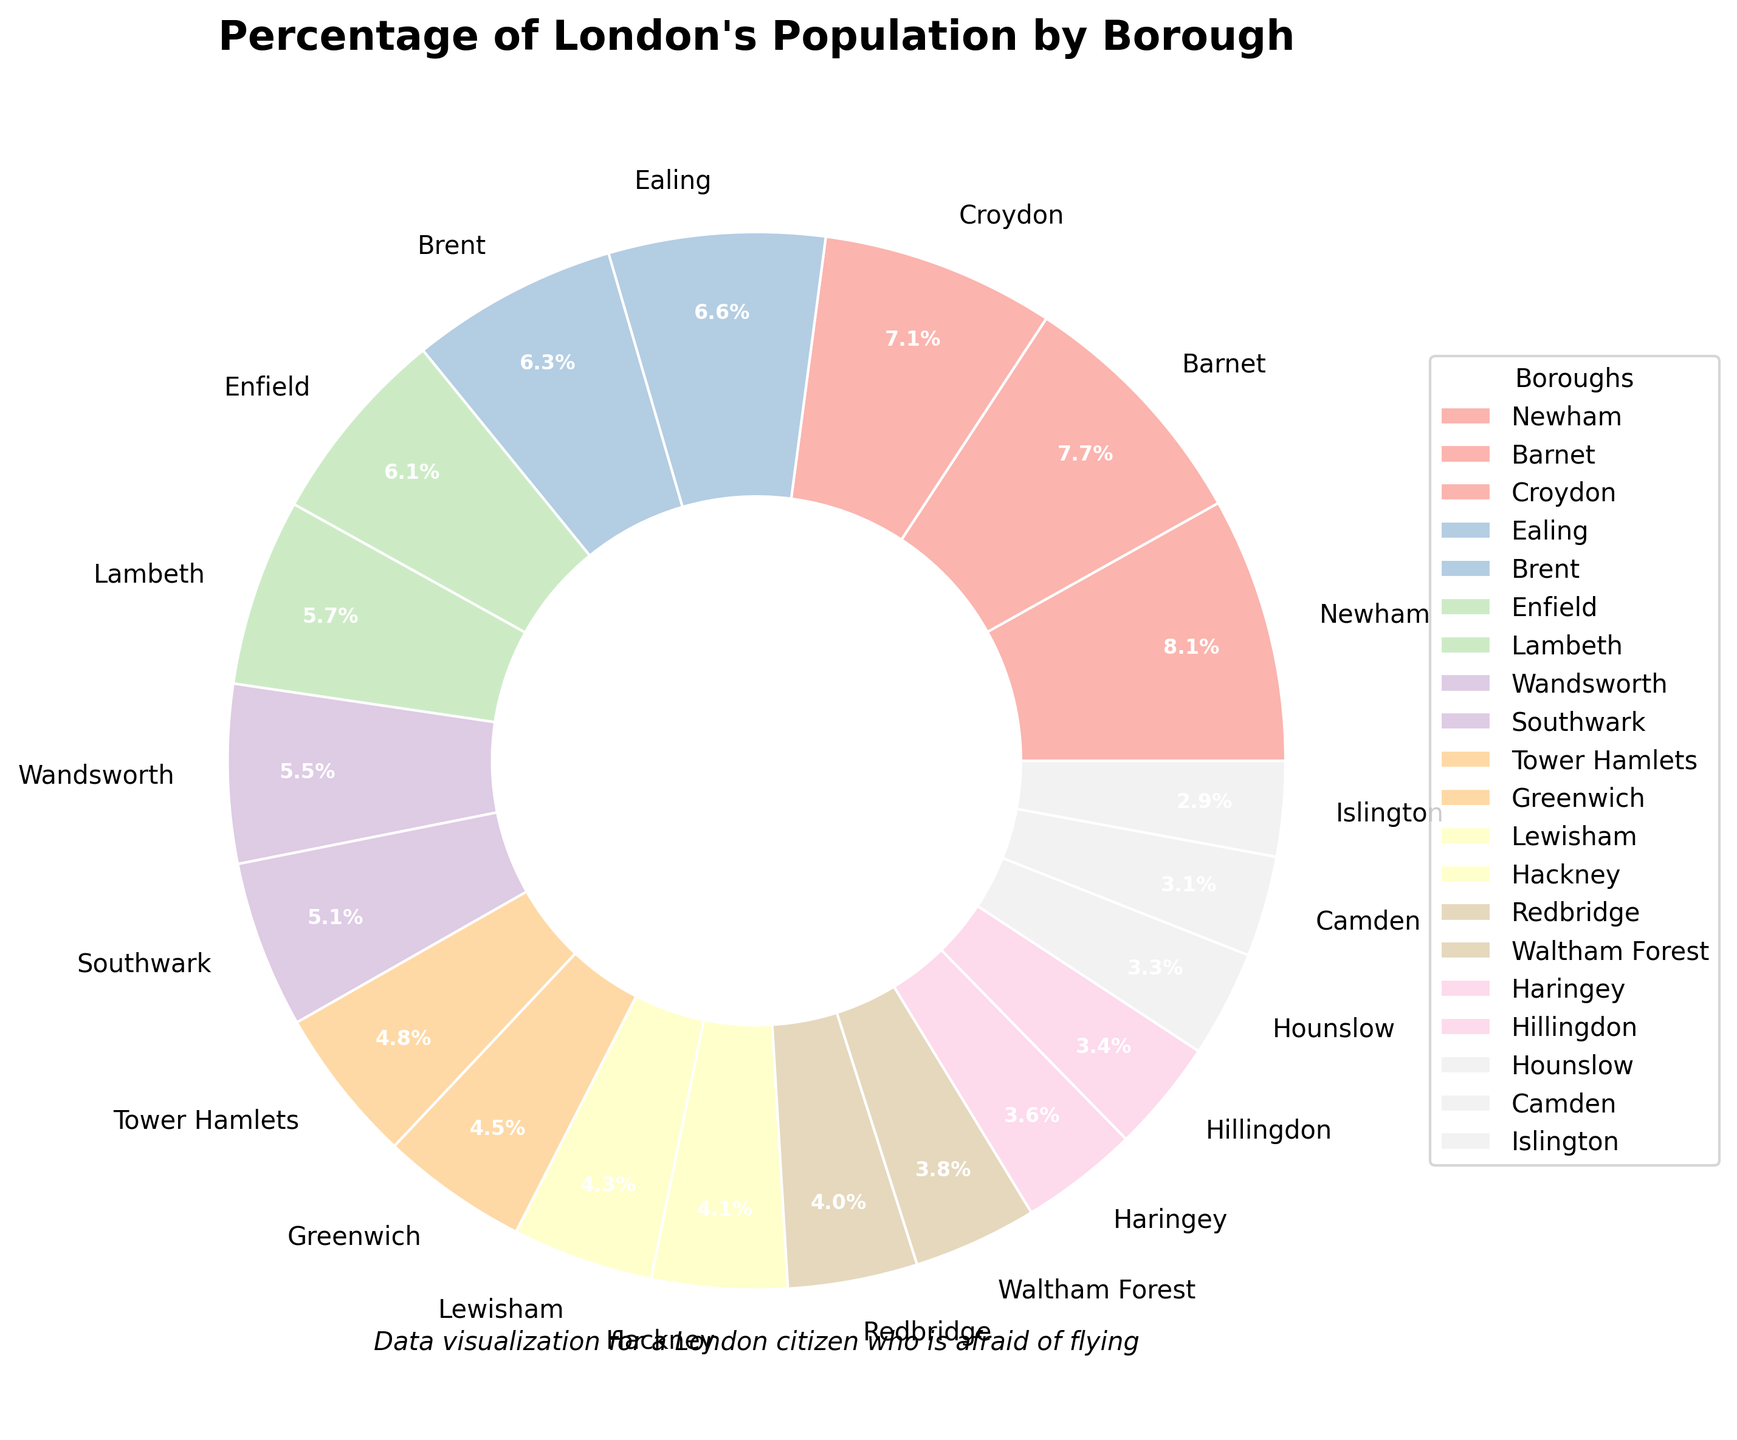What percentage of London's population is represented by Ealing and Brent combined? Ealing's percentage is 7.5 and Brent's percentage is 7.2. Add these percentages together: 7.5 + 7.2 = 14.7
Answer: 14.7 Which borough has the highest percentage of London's population? The borough with the largest percentage in the pie chart is Newham, which has 9.2%
Answer: Newham Among Lambeth, Islington, and Haringey, which borough has the smallest population percentage? Lambeth is 6.5%, Islington is 3.3%, and Haringey is 4.1%. The smallest percentage among these is Islington's 3.3%
Answer: Islington What is the difference in population percentage between Wandsworth and Camden? Wandsworth's percentage is 6.2 and Camden's percentage is 3.5. Subtract Camden's percentage from Wandsworth's: 6.2 - 3.5 = 2.7
Answer: 2.7 Which boroughs have a population percentage greater than 7%? The boroughs with percentages over 7% in the pie chart are Newham (9.2%), Barnet (8.7%), Croydon (8.1%), Ealing (7.5%), and Brent (7.2%)
Answer: Newham, Barnet, Croydon, Ealing, Brent How many boroughs have a population percentage less than 5%? The boroughs with percentages less than 5% are Lewisham (4.9%), Hackney (4.7%), Redbridge (4.5%), Waltham Forest (4.3%), Haringey (4.1%), Hillingdon (3.9%), Hounslow (3.7%), Camden (3.5%), and Islington (3.3%). Counting them gives us 9 boroughs.
Answer: 9 Compare the population percentages of Enfield and Waltham Forest. Which one is larger? Enfield's percentage is 6.9 and Waltham Forest's percentage is 4.3. Enfield's percentage is larger.
Answer: Enfield What percentage of London's population is represented by the three boroughs with the highest percentages? The three boroughs with the highest percentages are Newham (9.2%), Barnet (8.7%), and Croydon (8.1%). Adding these gives: 9.2 + 8.7 + 8.1 = 26.0%
Answer: 26.0 What visual elements differentiate the boroughs on the pie chart? The boroughs are differentiated by colors from the Pastel1 color palette and labeled with their names and percentages. Each wedge has an outer ring and labels in white text.
Answer: Colors, labels Considering Brent, Lambeth, and Southwark, what's their average population percentage? The percentages for Brent, Lambeth, and Southwark are 7.2, 6.5, and 5.8 respectively. Their sum is: 7.2 + 6.5 + 5.8 = 19.5. The average is: 19.5 / 3 = 6.5
Answer: 6.5 